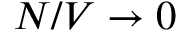Convert formula to latex. <formula><loc_0><loc_0><loc_500><loc_500>N / V \to 0</formula> 